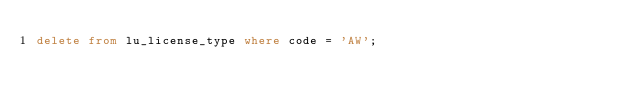<code> <loc_0><loc_0><loc_500><loc_500><_SQL_>delete from lu_license_type where code = 'AW';</code> 